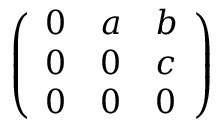<formula> <loc_0><loc_0><loc_500><loc_500>\left ( \begin{array} { l l l } { 0 } & { a } & { b } \\ { 0 } & { 0 } & { c } \\ { 0 } & { 0 } & { 0 } \end{array} \right )</formula> 